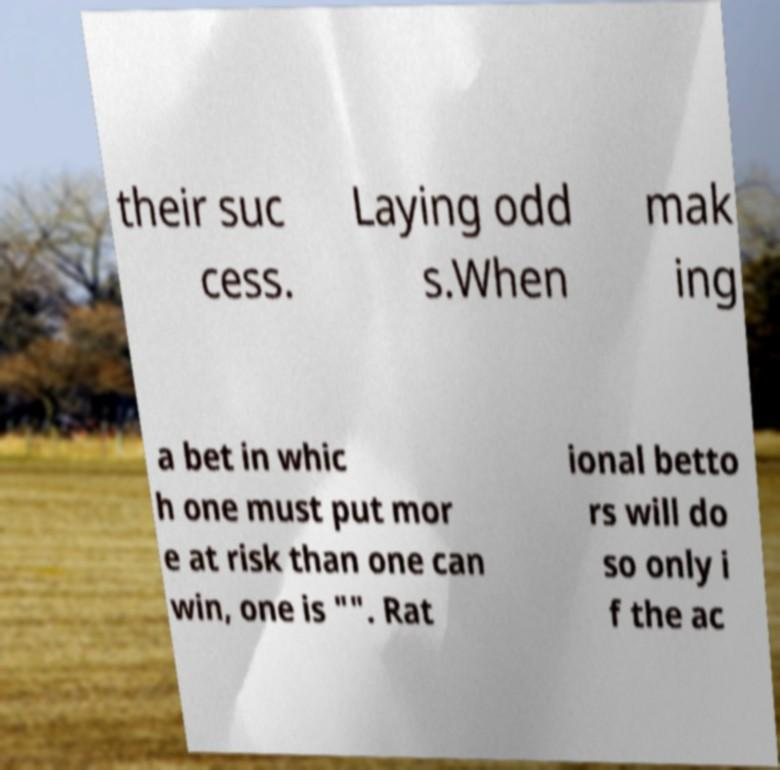Please read and relay the text visible in this image. What does it say? their suc cess. Laying odd s.When mak ing a bet in whic h one must put mor e at risk than one can win, one is "". Rat ional betto rs will do so only i f the ac 